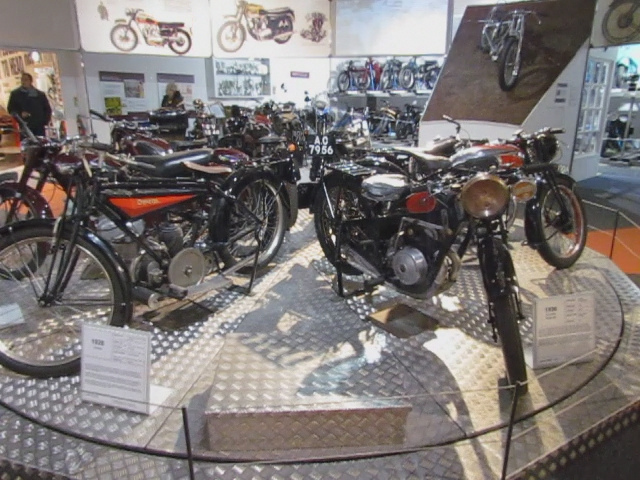What sort of shop is this?
A. used car
B. motorcycle repair
C. motorcycle sales
D. car sales This appears to be a motorcycle sales shop, considering the polished presentation of the motorcycles, complete with labels and signs that likely provide information about the make, model, and history of the vehicles, as well as their sale conditions. 